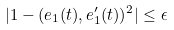Convert formula to latex. <formula><loc_0><loc_0><loc_500><loc_500>| 1 - ( { e } _ { 1 } ( t ) , { e } _ { 1 } ^ { \prime } ( t ) ) ^ { 2 } | \leq \epsilon</formula> 